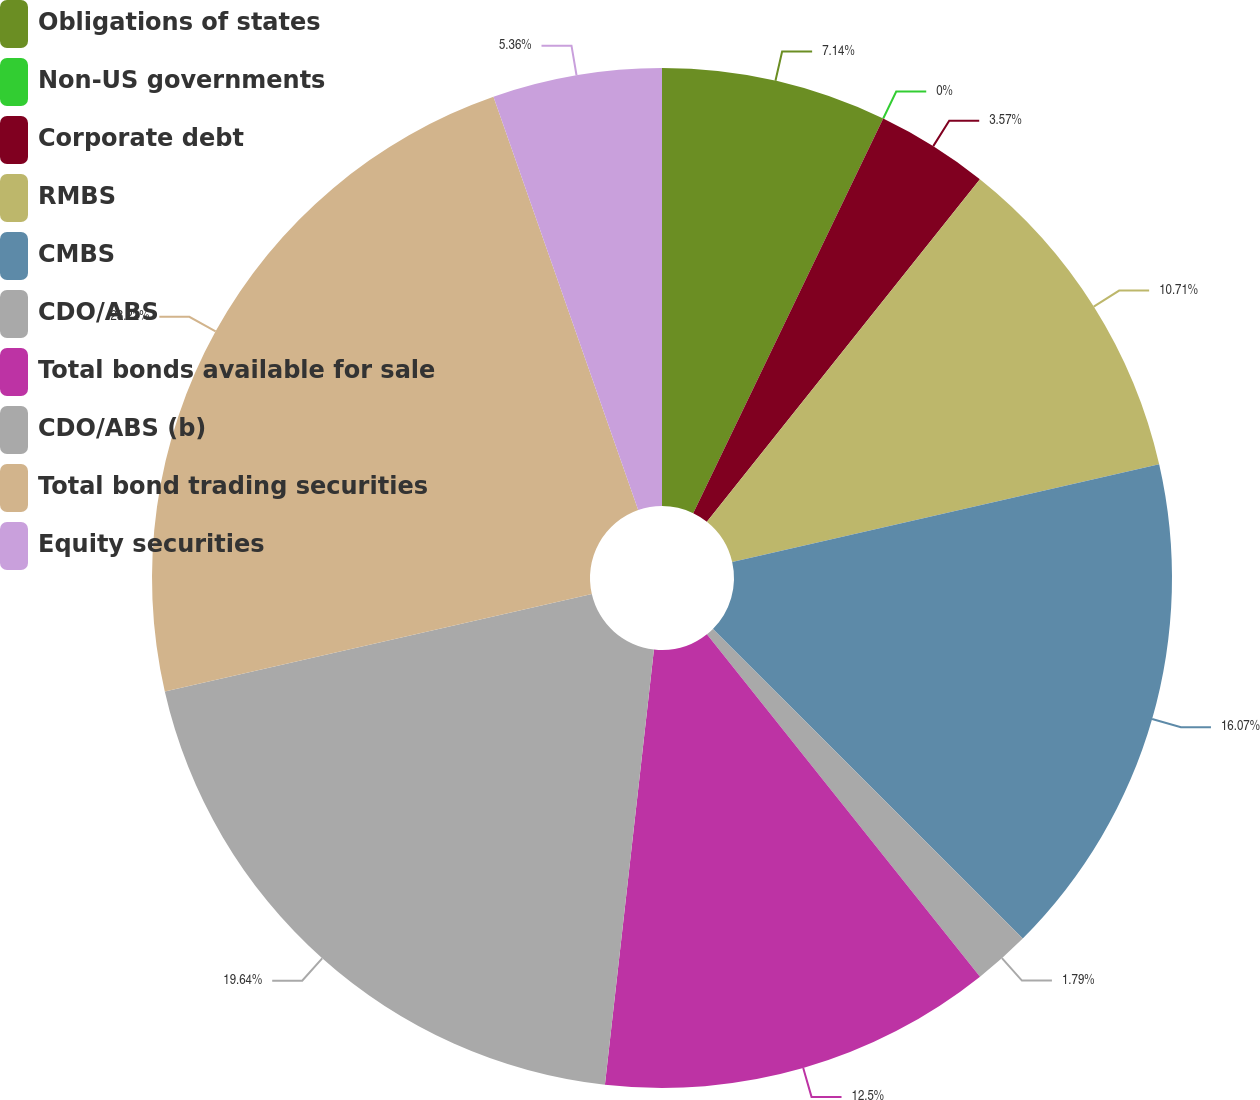Convert chart to OTSL. <chart><loc_0><loc_0><loc_500><loc_500><pie_chart><fcel>Obligations of states<fcel>Non-US governments<fcel>Corporate debt<fcel>RMBS<fcel>CMBS<fcel>CDO/ABS<fcel>Total bonds available for sale<fcel>CDO/ABS (b)<fcel>Total bond trading securities<fcel>Equity securities<nl><fcel>7.14%<fcel>0.0%<fcel>3.57%<fcel>10.71%<fcel>16.07%<fcel>1.79%<fcel>12.5%<fcel>19.64%<fcel>23.21%<fcel>5.36%<nl></chart> 